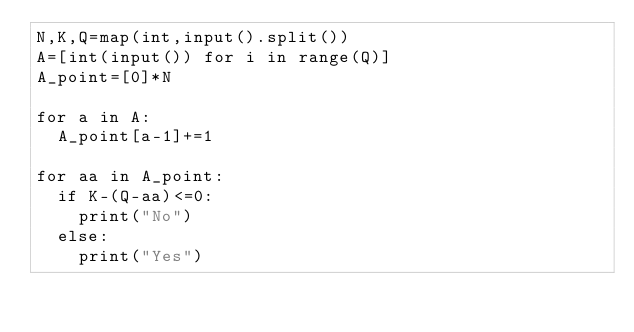Convert code to text. <code><loc_0><loc_0><loc_500><loc_500><_Python_>N,K,Q=map(int,input().split())
A=[int(input()) for i in range(Q)]
A_point=[0]*N

for a in A:
  A_point[a-1]+=1

for aa in A_point:
  if K-(Q-aa)<=0:
    print("No")
  else:
    print("Yes")
  
  </code> 